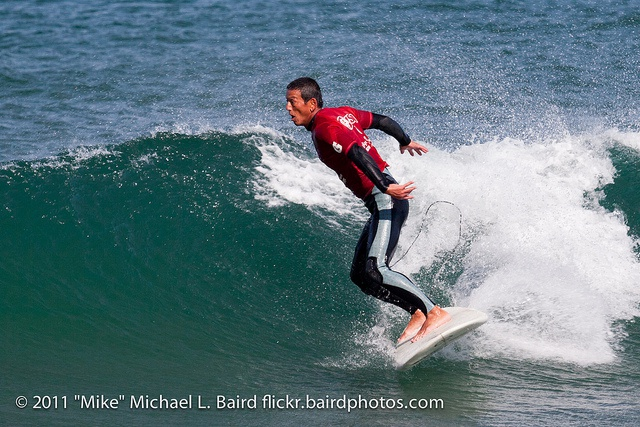Describe the objects in this image and their specific colors. I can see people in blue, black, lightgray, darkgray, and brown tones and surfboard in blue, lightgray, gray, and darkgray tones in this image. 